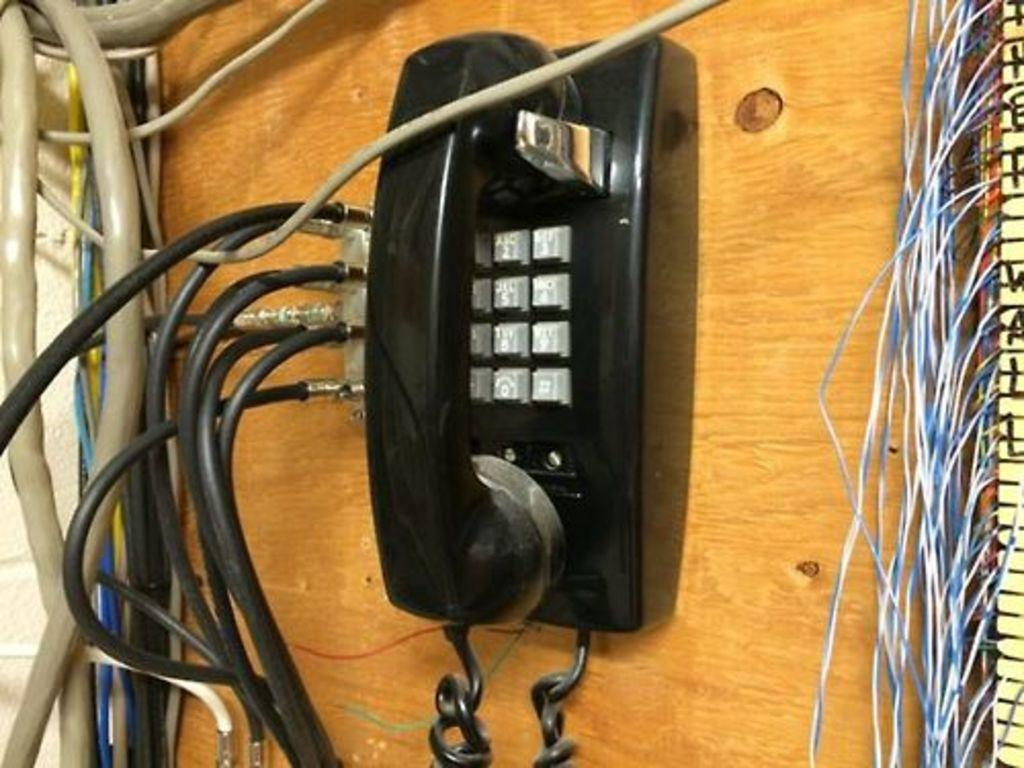What type of surface is present in the image? There is a wooden surface in the image. What object can be seen on the wooden surface? There is a telephone in the image. What else is visible on or near the wooden surface? Cables are visible in the image. What type of ship can be seen sailing in the background of the image? There is no ship visible in the image; it only features a wooden surface, a telephone, and cables. 